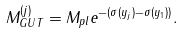Convert formula to latex. <formula><loc_0><loc_0><loc_500><loc_500>M _ { G U T } ^ { ( j ) } = M _ { p l } e ^ { - ( \sigma ( y _ { j } ) - \sigma ( y _ { 1 } ) ) } . \,</formula> 